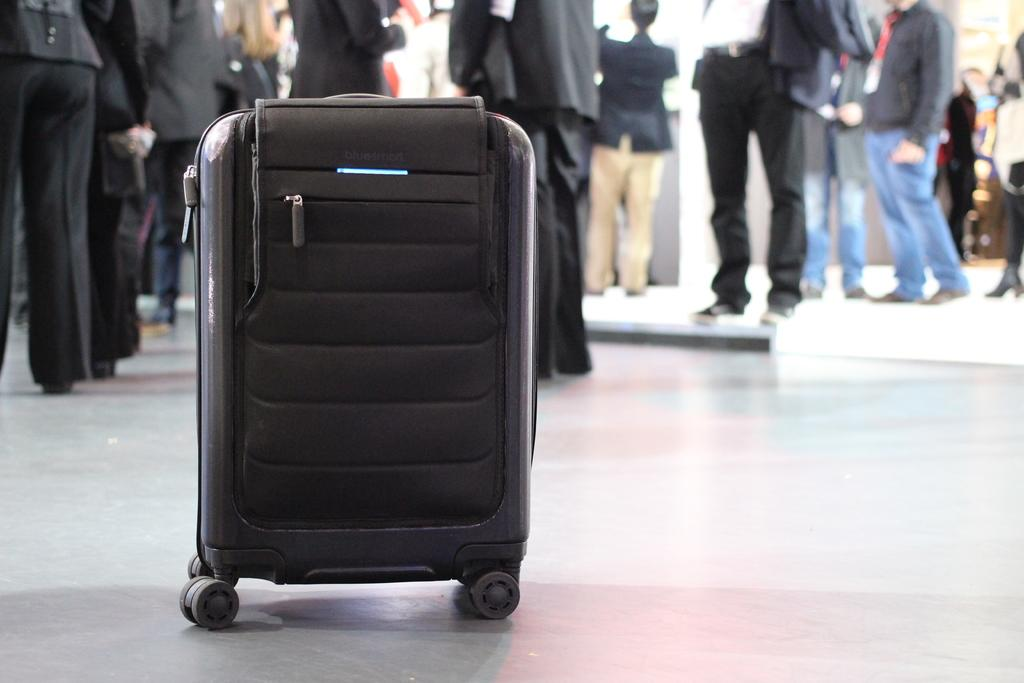What object can be seen in the image? There is a briefcase in the image. What surface is visible in the image? The image shows a floor. Are there any people present in the image? Yes, there are people standing on the floor in the image. What type of orange is being used to plough the field in the image? There is no orange or plough present in the image; it only shows a briefcase and people standing on a floor. 